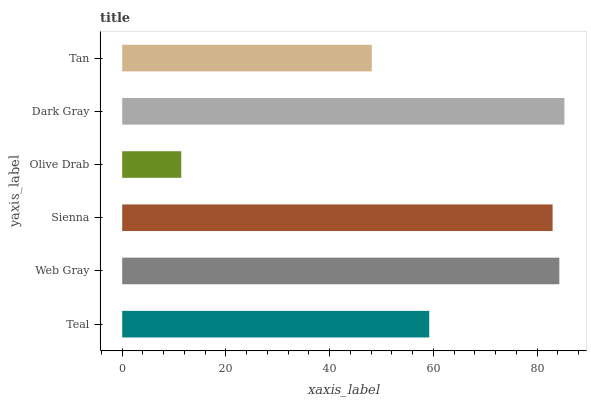Is Olive Drab the minimum?
Answer yes or no. Yes. Is Dark Gray the maximum?
Answer yes or no. Yes. Is Web Gray the minimum?
Answer yes or no. No. Is Web Gray the maximum?
Answer yes or no. No. Is Web Gray greater than Teal?
Answer yes or no. Yes. Is Teal less than Web Gray?
Answer yes or no. Yes. Is Teal greater than Web Gray?
Answer yes or no. No. Is Web Gray less than Teal?
Answer yes or no. No. Is Sienna the high median?
Answer yes or no. Yes. Is Teal the low median?
Answer yes or no. Yes. Is Olive Drab the high median?
Answer yes or no. No. Is Web Gray the low median?
Answer yes or no. No. 